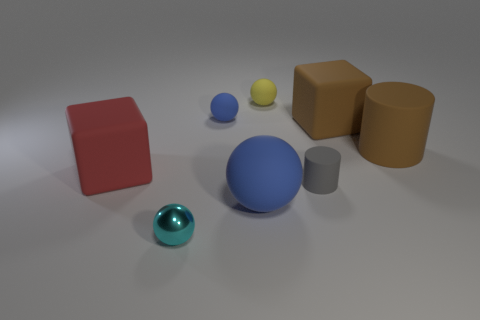Subtract all tiny blue spheres. How many spheres are left? 3 Subtract all blue balls. How many balls are left? 2 Subtract 2 cubes. How many cubes are left? 0 Add 2 big brown metallic cylinders. How many objects exist? 10 Subtract all blocks. How many objects are left? 6 Subtract 1 brown cylinders. How many objects are left? 7 Subtract all cyan cylinders. Subtract all gray cubes. How many cylinders are left? 2 Subtract all purple blocks. How many blue balls are left? 2 Subtract all large brown blocks. Subtract all rubber blocks. How many objects are left? 5 Add 1 big blue balls. How many big blue balls are left? 2 